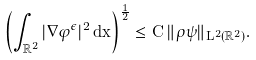<formula> <loc_0><loc_0><loc_500><loc_500>\left ( \int _ { \mathbb { R } ^ { 2 } } | \nabla \varphi ^ { \epsilon } | ^ { 2 } \, d x \right ) ^ { \frac { 1 } { 2 } } \leq C \, \| \rho \psi \| _ { L ^ { 2 } ( \mathbb { R } ^ { 2 } ) } .</formula> 